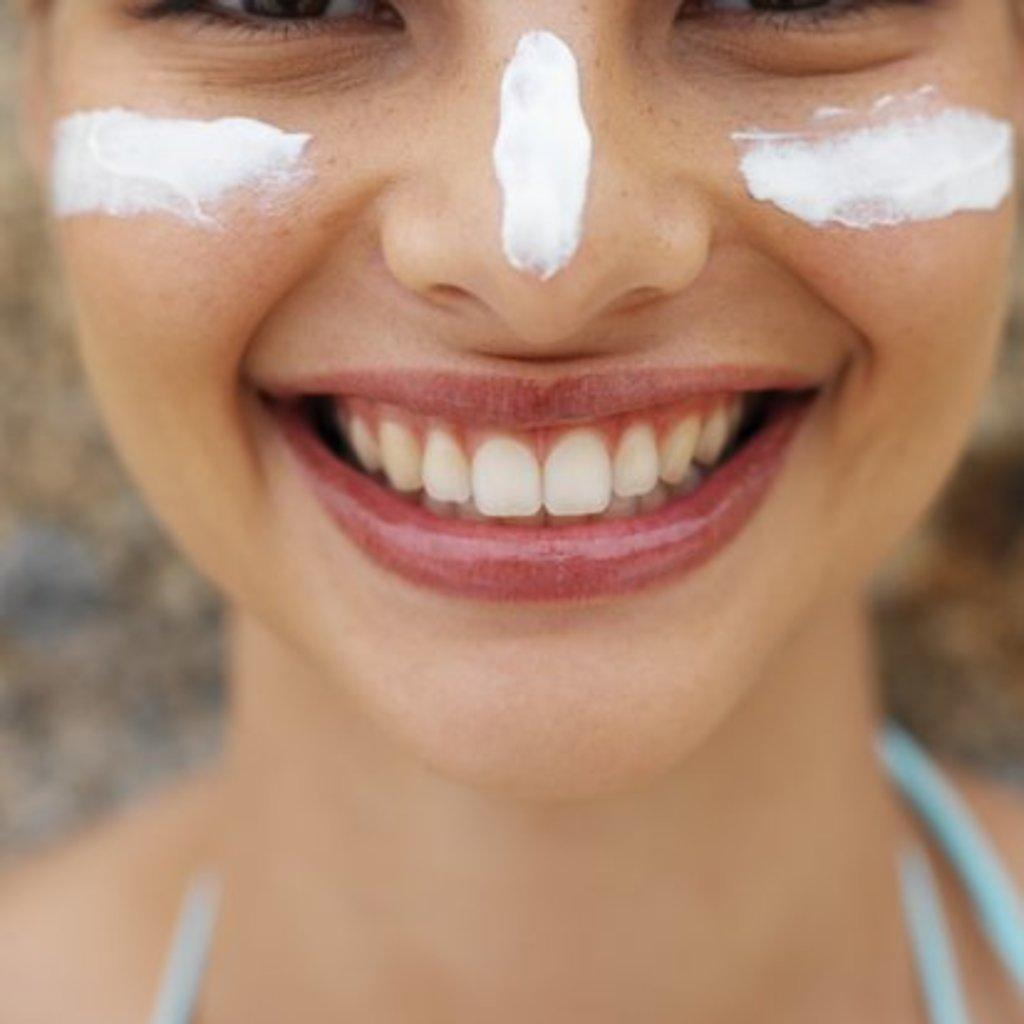What is the main subject of the image? There is a woman's face in the image. What is applied to the woman's face? There is cream on the woman's face. Can you describe the background of the image? The background of the image is blurred. What is the woman's opinion on the new rule in the image? There is no indication of a new rule or the woman's opinion in the image. What type of vegetable can be seen growing in the background of the image? There is no vegetable visible in the image, as the background is blurred. 